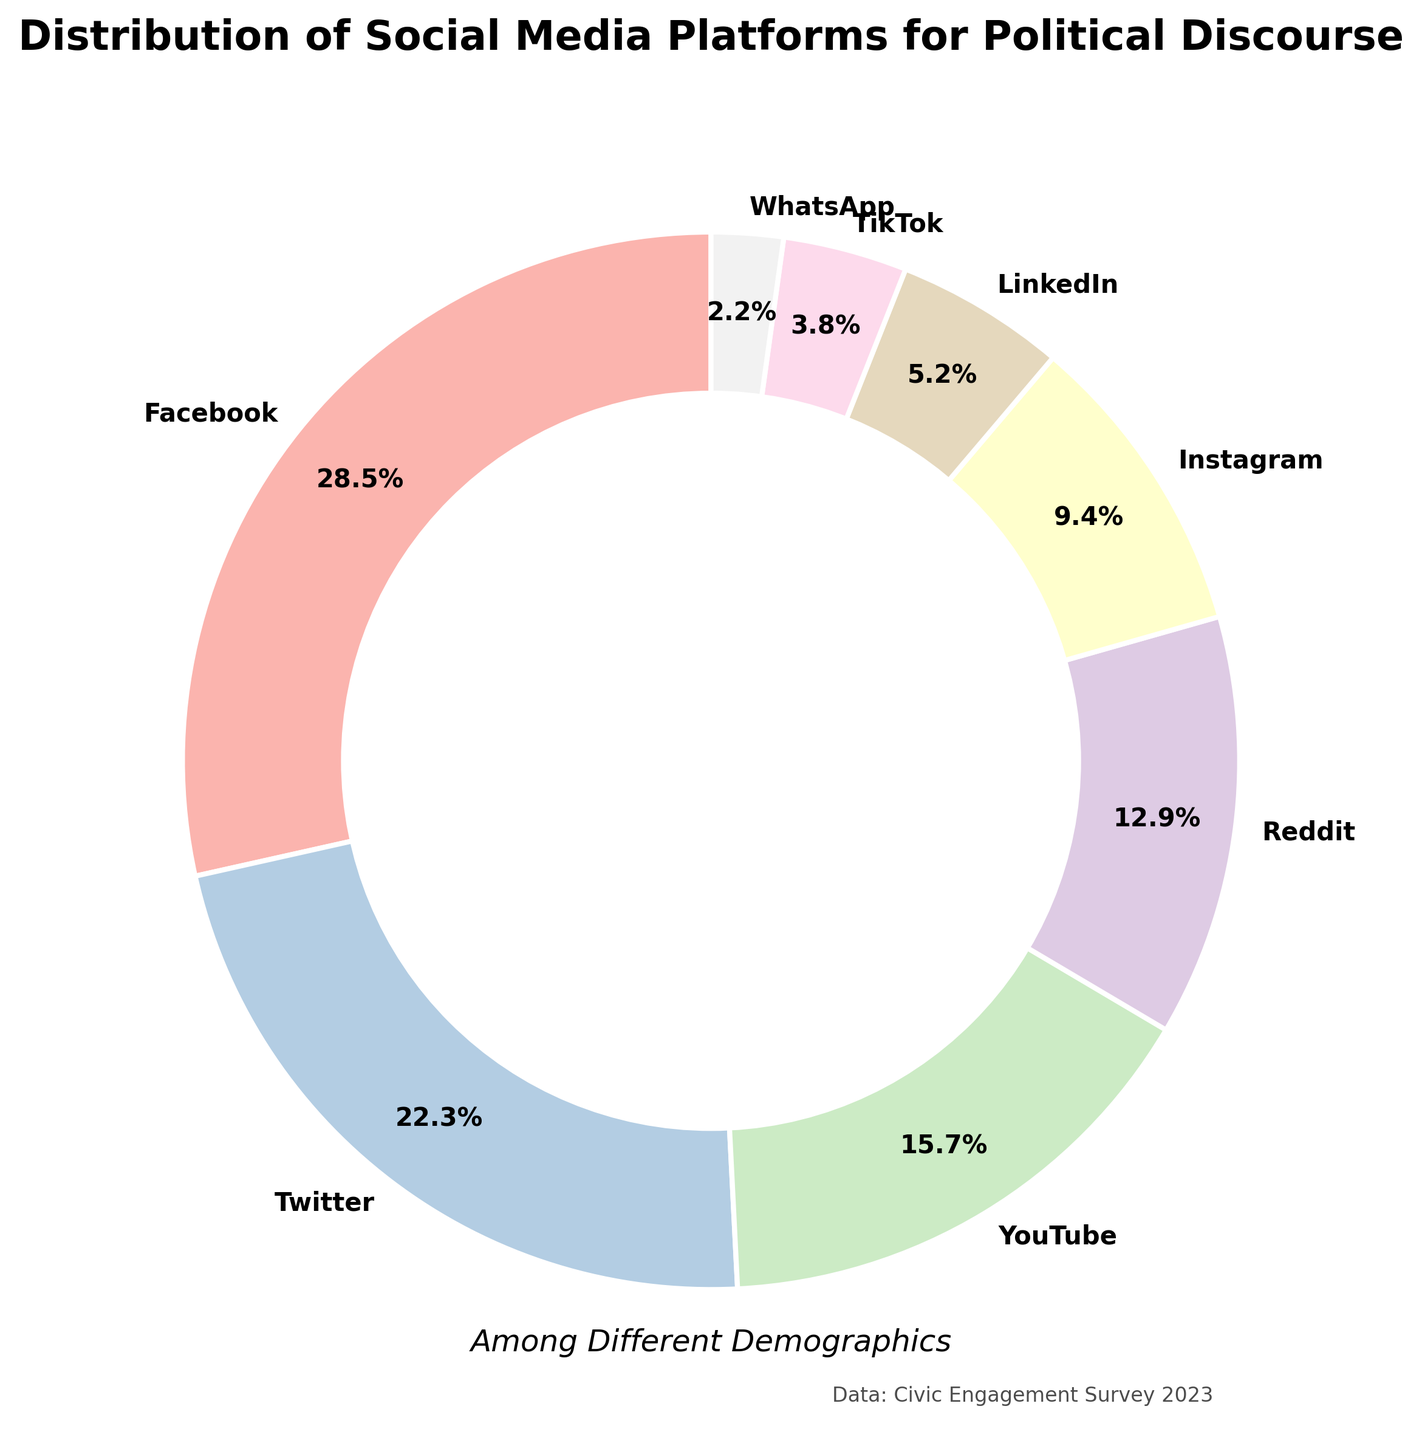Which social media platform has the highest usage for political discourse? According to the pie chart, the largest segment is labeled with 28.5%, which corresponds to Facebook.
Answer: Facebook What is the total percentage of platforms with usage below 10%? Summing up the percentages for Instagram (9.4%), LinkedIn (5.2%), TikTok (3.8%), and WhatsApp (2.2%) gives 9.4% + 5.2% + 3.8% + 2.2% = 20.6%.
Answer: 20.6% How much greater is Facebook's usage compared to Reddit's? Facebook's usage is 28.5% and Reddit's usage is 12.9%. The difference is 28.5% - 12.9% = 15.6%.
Answer: 15.6% Which platform has the smallest usage for political discourse? The smallest percentage in the pie chart is 2.2%, which corresponds to WhatsApp.
Answer: WhatsApp Is the combined usage of Twitter and YouTube more or less than Facebook's usage? Twitter's usage is 22.3% and YouTube's usage is 15.7%. Combined, this is 22.3% + 15.7% = 38%, which is more than Facebook's 28.5%.
Answer: More If Facebook and Twitter's usage are combined, what percentage of the total does this represent? Adding Facebook's 28.5% and Twitter's 22.3% gives 28.5% + 22.3% = 50.8%.
Answer: 50.8% Rank the platforms from highest to lowest usage percentage. The platforms, ordered from highest to lowest usage, are: Facebook (28.5%), Twitter (22.3%), YouTube (15.7%), Reddit (12.9%), Instagram (9.4%), LinkedIn (5.2%), TikTok (3.8%), WhatsApp (2.2%).
Answer: Facebook, Twitter, YouTube, Reddit, Instagram, LinkedIn, TikTok, WhatsApp What is the average usage percentage of LinkedIn and TikTok combined? Adding LinkedIn's 5.2% and TikTok's 3.8% gives 5.2% + 3.8% = 9%. The average is 9% / 2 = 4.5%.
Answer: 4.5% What is the visual difference between the wedge representing YouTube and the wedge representing Instagram? The wedge representing YouTube is larger than the wedge representing Instagram. YouTube has a percentage of 15.7%, while Instagram has 9.4%.
Answer: YouTube's wedge is larger 